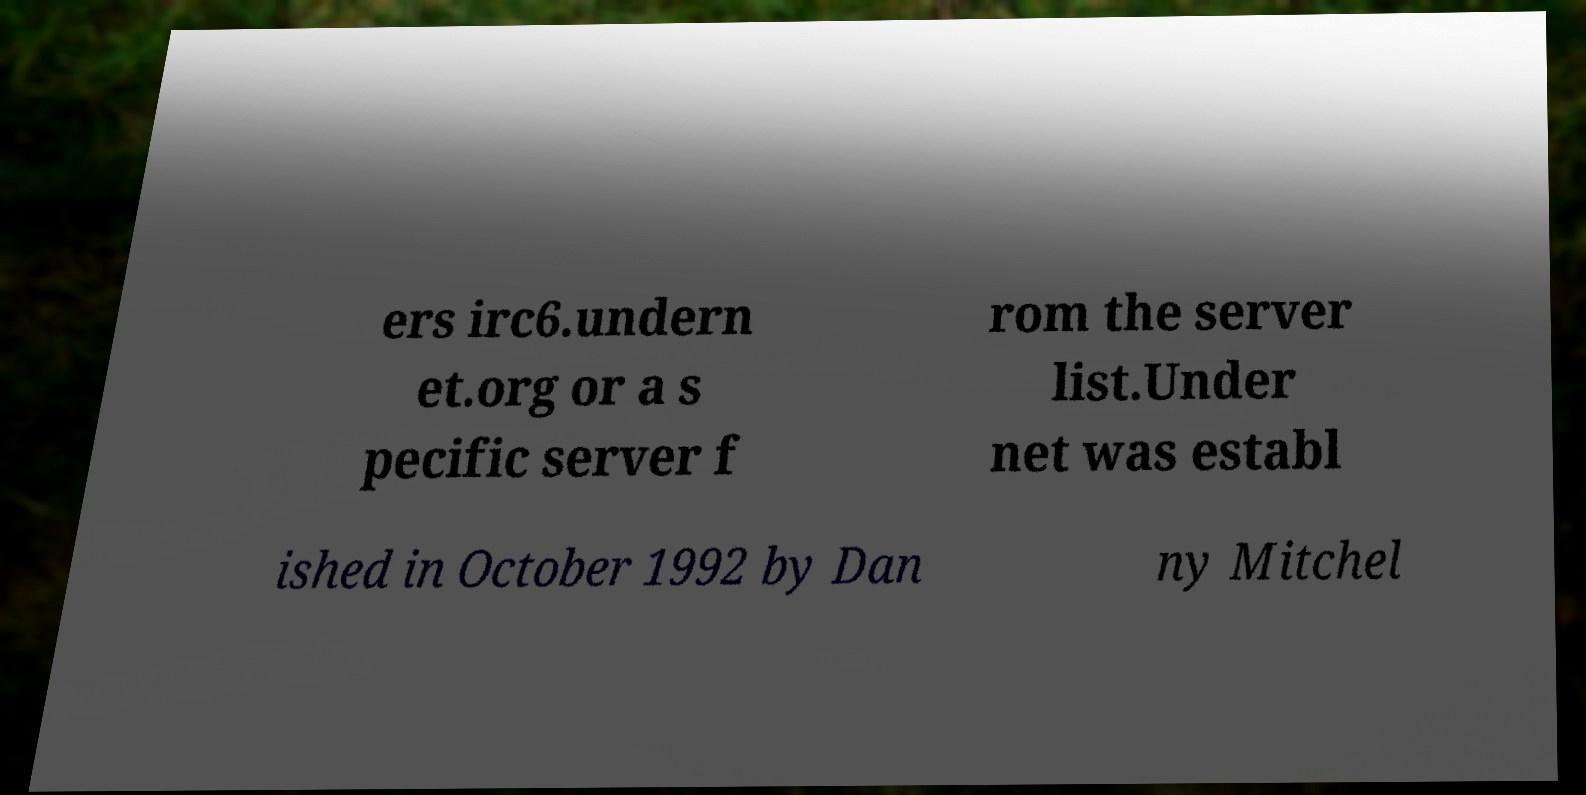Please read and relay the text visible in this image. What does it say? ers irc6.undern et.org or a s pecific server f rom the server list.Under net was establ ished in October 1992 by Dan ny Mitchel 